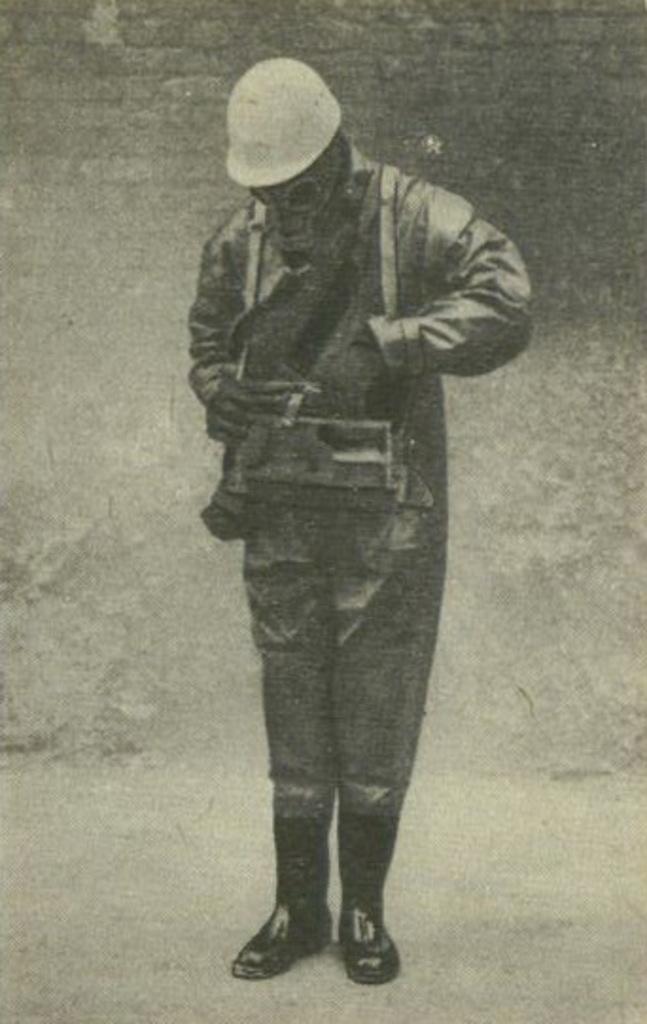In one or two sentences, can you explain what this image depicts? In this image we can see a black and white picture of a person wearing uniform,helmet and a mask. 